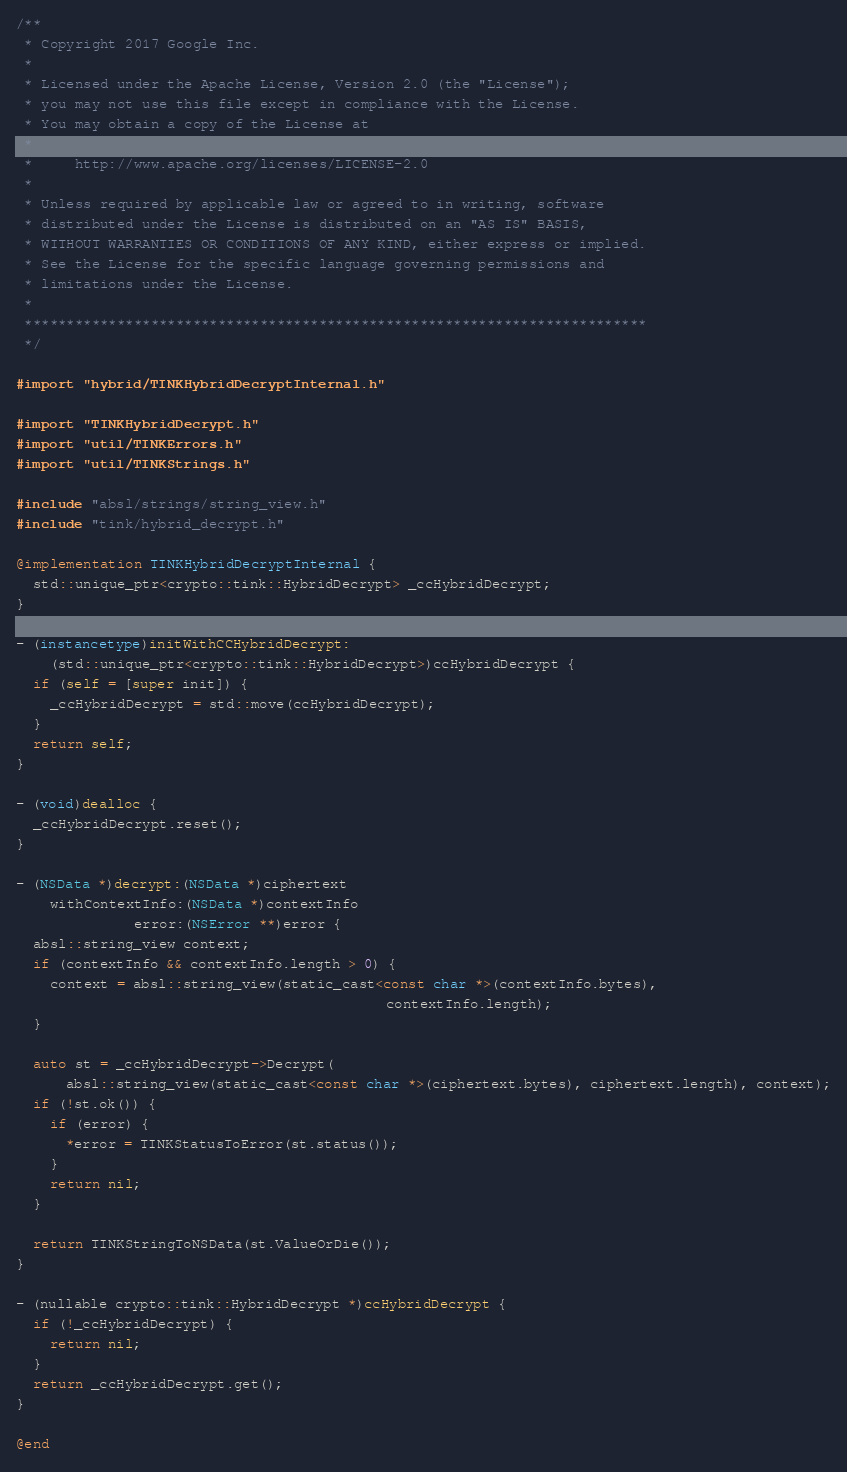Convert code to text. <code><loc_0><loc_0><loc_500><loc_500><_ObjectiveC_>/**
 * Copyright 2017 Google Inc.
 *
 * Licensed under the Apache License, Version 2.0 (the "License");
 * you may not use this file except in compliance with the License.
 * You may obtain a copy of the License at
 *
 *     http://www.apache.org/licenses/LICENSE-2.0
 *
 * Unless required by applicable law or agreed to in writing, software
 * distributed under the License is distributed on an "AS IS" BASIS,
 * WITHOUT WARRANTIES OR CONDITIONS OF ANY KIND, either express or implied.
 * See the License for the specific language governing permissions and
 * limitations under the License.
 *
 **************************************************************************
 */

#import "hybrid/TINKHybridDecryptInternal.h"

#import "TINKHybridDecrypt.h"
#import "util/TINKErrors.h"
#import "util/TINKStrings.h"

#include "absl/strings/string_view.h"
#include "tink/hybrid_decrypt.h"

@implementation TINKHybridDecryptInternal {
  std::unique_ptr<crypto::tink::HybridDecrypt> _ccHybridDecrypt;
}

- (instancetype)initWithCCHybridDecrypt:
    (std::unique_ptr<crypto::tink::HybridDecrypt>)ccHybridDecrypt {
  if (self = [super init]) {
    _ccHybridDecrypt = std::move(ccHybridDecrypt);
  }
  return self;
}

- (void)dealloc {
  _ccHybridDecrypt.reset();
}

- (NSData *)decrypt:(NSData *)ciphertext
    withContextInfo:(NSData *)contextInfo
              error:(NSError **)error {
  absl::string_view context;
  if (contextInfo && contextInfo.length > 0) {
    context = absl::string_view(static_cast<const char *>(contextInfo.bytes),
                                            contextInfo.length);
  }

  auto st = _ccHybridDecrypt->Decrypt(
      absl::string_view(static_cast<const char *>(ciphertext.bytes), ciphertext.length), context);
  if (!st.ok()) {
    if (error) {
      *error = TINKStatusToError(st.status());
    }
    return nil;
  }

  return TINKStringToNSData(st.ValueOrDie());
}

- (nullable crypto::tink::HybridDecrypt *)ccHybridDecrypt {
  if (!_ccHybridDecrypt) {
    return nil;
  }
  return _ccHybridDecrypt.get();
}

@end
</code> 